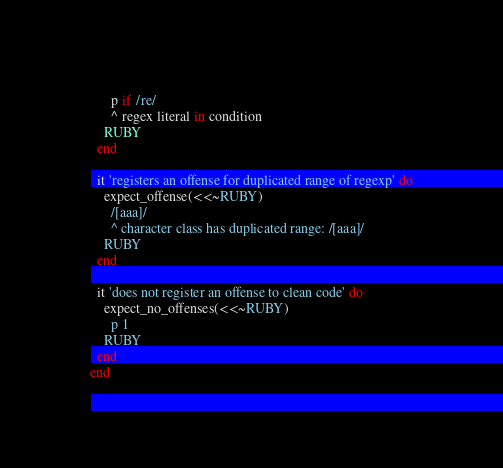<code> <loc_0><loc_0><loc_500><loc_500><_Ruby_>      p if /re/
      ^ regex literal in condition
    RUBY
  end

  it 'registers an offense for duplicated range of regexp' do
    expect_offense(<<~RUBY)
      /[aaa]/
      ^ character class has duplicated range: /[aaa]/
    RUBY
  end

  it 'does not register an offense to clean code' do
    expect_no_offenses(<<~RUBY)
      p 1
    RUBY
  end
end
</code> 